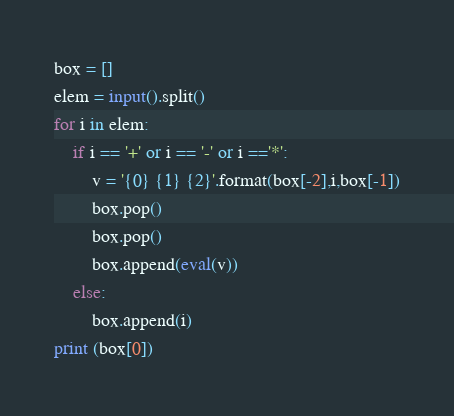<code> <loc_0><loc_0><loc_500><loc_500><_Python_>box = []
elem = input().split()
for i in elem:
    if i == '+' or i == '-' or i =='*':
        v = '{0} {1} {2}'.format(box[-2],i,box[-1])
        box.pop()
        box.pop()
        box.append(eval(v))
    else:
        box.append(i)
print (box[0])</code> 